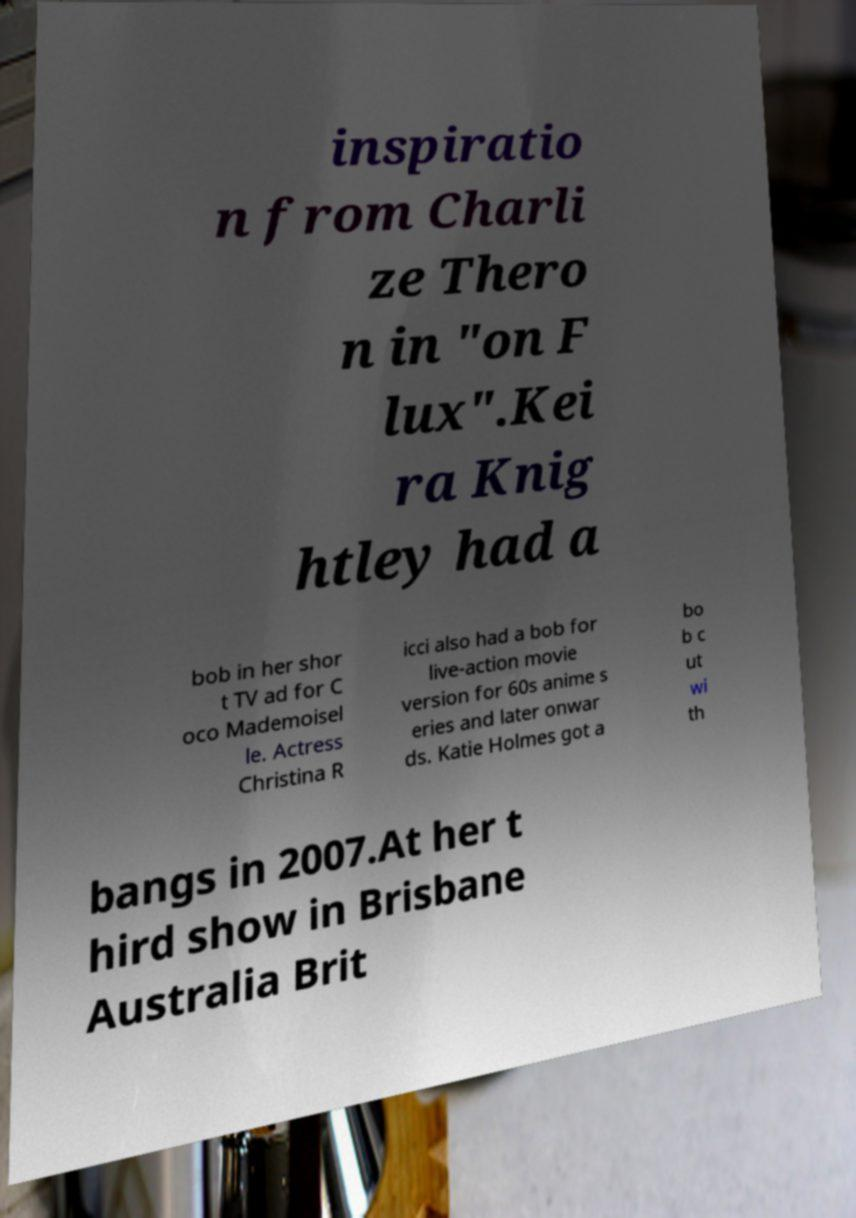Could you assist in decoding the text presented in this image and type it out clearly? inspiratio n from Charli ze Thero n in "on F lux".Kei ra Knig htley had a bob in her shor t TV ad for C oco Mademoisel le. Actress Christina R icci also had a bob for live-action movie version for 60s anime s eries and later onwar ds. Katie Holmes got a bo b c ut wi th bangs in 2007.At her t hird show in Brisbane Australia Brit 